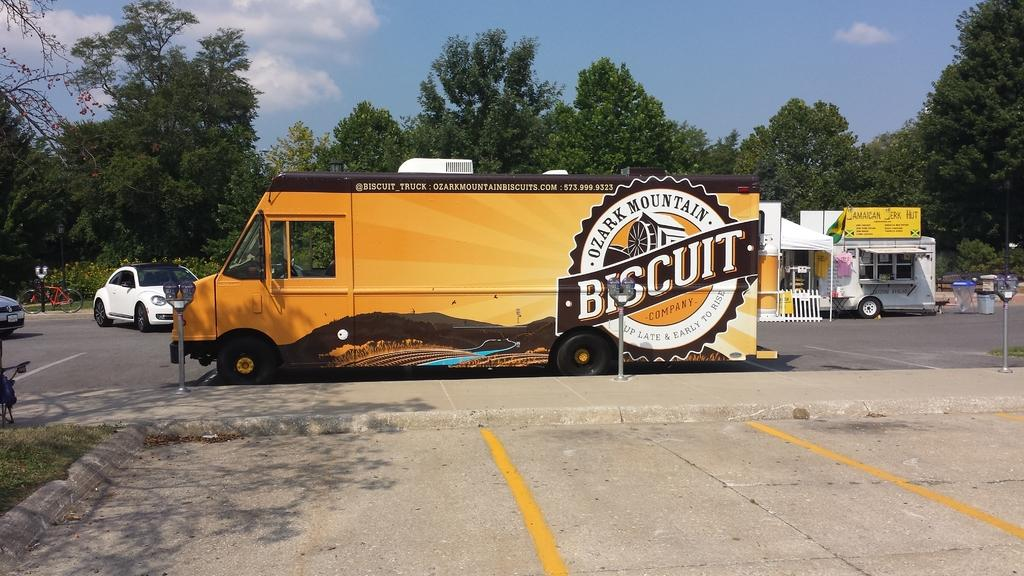What can be seen on the road in the image? There are vehicles on the road in the image. What else is present in the image besides the vehicles? There are objects, poles, plants, trees, and grass in the image. What is visible in the background of the image? The sky is visible in the background of the image. What instrument does the beginner play in the image? There is no beginner or instrument present in the image. 